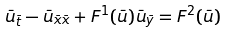<formula> <loc_0><loc_0><loc_500><loc_500>\bar { u } _ { \bar { t } } - \bar { u } _ { \bar { x } \bar { x } } + F ^ { 1 } ( \bar { u } ) \bar { u } _ { \bar { y } } = F ^ { 2 } ( \bar { u } )</formula> 